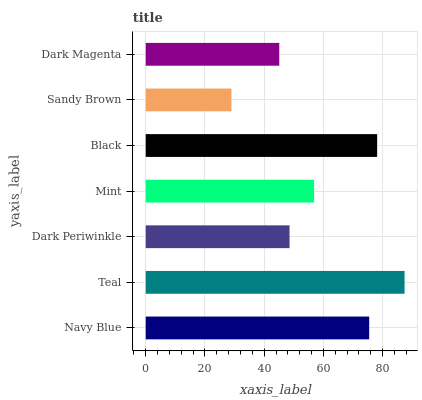Is Sandy Brown the minimum?
Answer yes or no. Yes. Is Teal the maximum?
Answer yes or no. Yes. Is Dark Periwinkle the minimum?
Answer yes or no. No. Is Dark Periwinkle the maximum?
Answer yes or no. No. Is Teal greater than Dark Periwinkle?
Answer yes or no. Yes. Is Dark Periwinkle less than Teal?
Answer yes or no. Yes. Is Dark Periwinkle greater than Teal?
Answer yes or no. No. Is Teal less than Dark Periwinkle?
Answer yes or no. No. Is Mint the high median?
Answer yes or no. Yes. Is Mint the low median?
Answer yes or no. Yes. Is Black the high median?
Answer yes or no. No. Is Teal the low median?
Answer yes or no. No. 